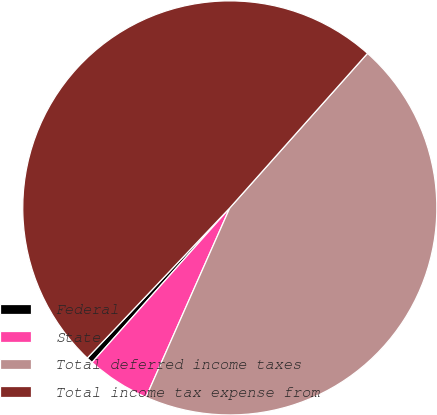Convert chart to OTSL. <chart><loc_0><loc_0><loc_500><loc_500><pie_chart><fcel>Federal<fcel>State<fcel>Total deferred income taxes<fcel>Total income tax expense from<nl><fcel>0.5%<fcel>4.95%<fcel>45.05%<fcel>49.5%<nl></chart> 